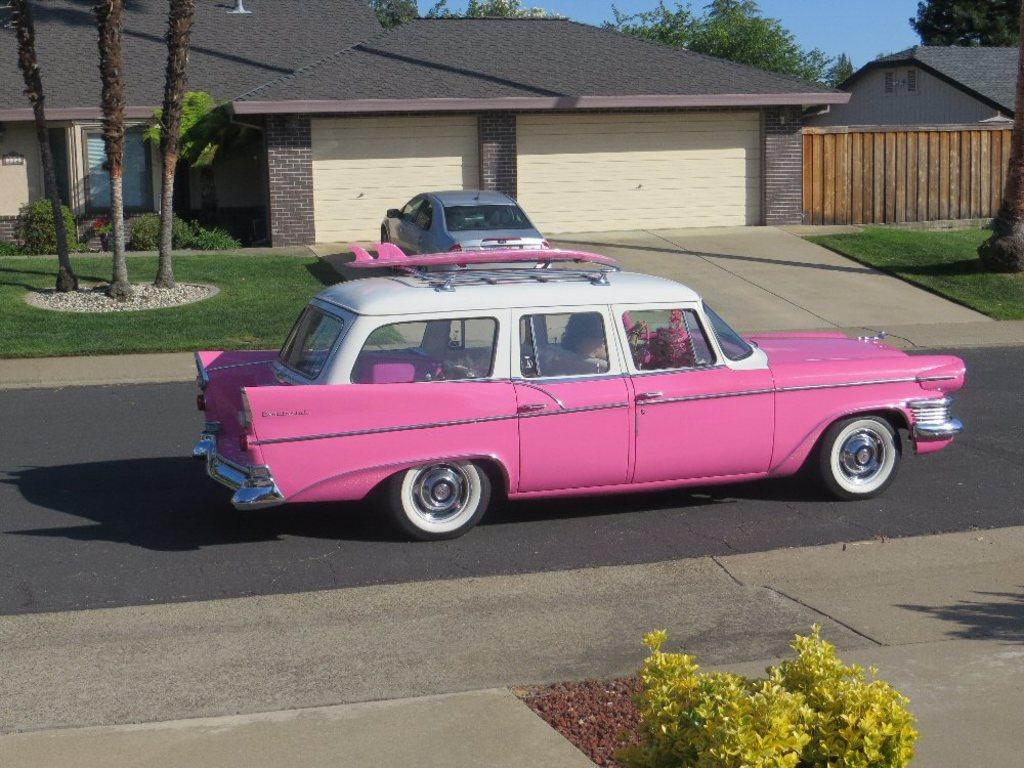What colors are the cars in the image? There is a pink color car and a silver color car in the image. What type of vegetation can be seen in the image? Plants, trees, and houses are visible in the image. What is the condition of the sky in the image? The sky is visible in the image. Are there any shadows present in the image? Yes, shadows are present in the image. What type of farm animals can be seen in the image? There are no farm animals present in the image. What is the bottle used for in the image? There is no bottle present in the image. 